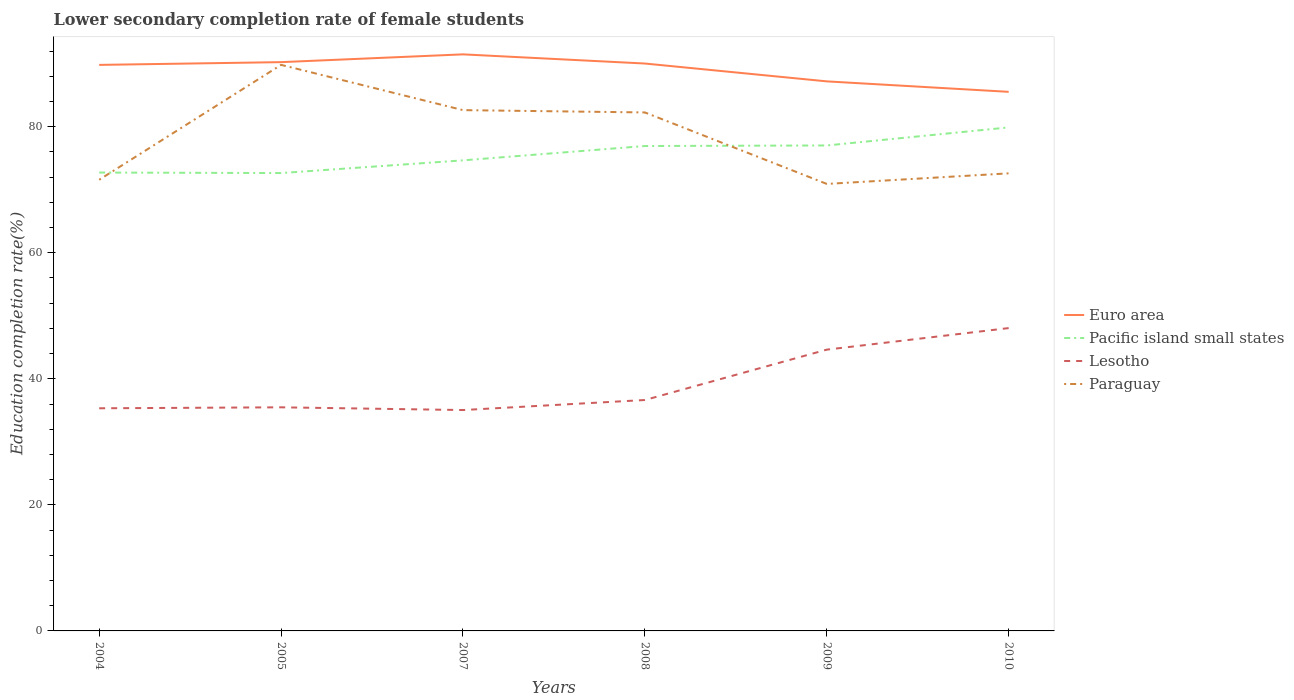Does the line corresponding to Lesotho intersect with the line corresponding to Paraguay?
Ensure brevity in your answer.  No. Across all years, what is the maximum lower secondary completion rate of female students in Euro area?
Ensure brevity in your answer.  85.53. What is the total lower secondary completion rate of female students in Lesotho in the graph?
Ensure brevity in your answer.  0.28. What is the difference between the highest and the second highest lower secondary completion rate of female students in Euro area?
Your response must be concise. 5.95. How many years are there in the graph?
Your response must be concise. 6. What is the difference between two consecutive major ticks on the Y-axis?
Your answer should be compact. 20. Where does the legend appear in the graph?
Ensure brevity in your answer.  Center right. How many legend labels are there?
Your response must be concise. 4. What is the title of the graph?
Your answer should be compact. Lower secondary completion rate of female students. What is the label or title of the X-axis?
Your response must be concise. Years. What is the label or title of the Y-axis?
Offer a very short reply. Education completion rate(%). What is the Education completion rate(%) of Euro area in 2004?
Your answer should be compact. 89.81. What is the Education completion rate(%) in Pacific island small states in 2004?
Your answer should be compact. 72.73. What is the Education completion rate(%) of Lesotho in 2004?
Make the answer very short. 35.32. What is the Education completion rate(%) of Paraguay in 2004?
Provide a succinct answer. 71.58. What is the Education completion rate(%) of Euro area in 2005?
Keep it short and to the point. 90.25. What is the Education completion rate(%) in Pacific island small states in 2005?
Give a very brief answer. 72.65. What is the Education completion rate(%) in Lesotho in 2005?
Ensure brevity in your answer.  35.48. What is the Education completion rate(%) of Paraguay in 2005?
Offer a very short reply. 89.81. What is the Education completion rate(%) in Euro area in 2007?
Keep it short and to the point. 91.48. What is the Education completion rate(%) of Pacific island small states in 2007?
Your answer should be compact. 74.66. What is the Education completion rate(%) of Lesotho in 2007?
Your answer should be very brief. 35.05. What is the Education completion rate(%) in Paraguay in 2007?
Offer a terse response. 82.63. What is the Education completion rate(%) in Euro area in 2008?
Your answer should be very brief. 90.03. What is the Education completion rate(%) in Pacific island small states in 2008?
Your answer should be compact. 76.94. What is the Education completion rate(%) in Lesotho in 2008?
Your answer should be compact. 36.64. What is the Education completion rate(%) of Paraguay in 2008?
Make the answer very short. 82.26. What is the Education completion rate(%) of Euro area in 2009?
Give a very brief answer. 87.19. What is the Education completion rate(%) in Pacific island small states in 2009?
Provide a succinct answer. 77.03. What is the Education completion rate(%) in Lesotho in 2009?
Offer a terse response. 44.63. What is the Education completion rate(%) in Paraguay in 2009?
Make the answer very short. 70.92. What is the Education completion rate(%) in Euro area in 2010?
Offer a very short reply. 85.53. What is the Education completion rate(%) in Pacific island small states in 2010?
Ensure brevity in your answer.  79.89. What is the Education completion rate(%) in Lesotho in 2010?
Offer a very short reply. 48.05. What is the Education completion rate(%) in Paraguay in 2010?
Make the answer very short. 72.6. Across all years, what is the maximum Education completion rate(%) of Euro area?
Offer a terse response. 91.48. Across all years, what is the maximum Education completion rate(%) of Pacific island small states?
Your response must be concise. 79.89. Across all years, what is the maximum Education completion rate(%) of Lesotho?
Provide a succinct answer. 48.05. Across all years, what is the maximum Education completion rate(%) in Paraguay?
Your response must be concise. 89.81. Across all years, what is the minimum Education completion rate(%) in Euro area?
Your answer should be very brief. 85.53. Across all years, what is the minimum Education completion rate(%) of Pacific island small states?
Ensure brevity in your answer.  72.65. Across all years, what is the minimum Education completion rate(%) of Lesotho?
Offer a very short reply. 35.05. Across all years, what is the minimum Education completion rate(%) of Paraguay?
Provide a short and direct response. 70.92. What is the total Education completion rate(%) of Euro area in the graph?
Your response must be concise. 534.29. What is the total Education completion rate(%) of Pacific island small states in the graph?
Give a very brief answer. 453.89. What is the total Education completion rate(%) of Lesotho in the graph?
Offer a very short reply. 235.16. What is the total Education completion rate(%) in Paraguay in the graph?
Offer a very short reply. 469.81. What is the difference between the Education completion rate(%) in Euro area in 2004 and that in 2005?
Offer a terse response. -0.44. What is the difference between the Education completion rate(%) of Pacific island small states in 2004 and that in 2005?
Provide a succinct answer. 0.08. What is the difference between the Education completion rate(%) of Lesotho in 2004 and that in 2005?
Your answer should be very brief. -0.15. What is the difference between the Education completion rate(%) in Paraguay in 2004 and that in 2005?
Offer a very short reply. -18.23. What is the difference between the Education completion rate(%) of Euro area in 2004 and that in 2007?
Provide a short and direct response. -1.67. What is the difference between the Education completion rate(%) in Pacific island small states in 2004 and that in 2007?
Ensure brevity in your answer.  -1.94. What is the difference between the Education completion rate(%) of Lesotho in 2004 and that in 2007?
Give a very brief answer. 0.28. What is the difference between the Education completion rate(%) in Paraguay in 2004 and that in 2007?
Give a very brief answer. -11.05. What is the difference between the Education completion rate(%) of Euro area in 2004 and that in 2008?
Your answer should be compact. -0.22. What is the difference between the Education completion rate(%) of Pacific island small states in 2004 and that in 2008?
Give a very brief answer. -4.21. What is the difference between the Education completion rate(%) in Lesotho in 2004 and that in 2008?
Your response must be concise. -1.31. What is the difference between the Education completion rate(%) of Paraguay in 2004 and that in 2008?
Your response must be concise. -10.68. What is the difference between the Education completion rate(%) of Euro area in 2004 and that in 2009?
Offer a very short reply. 2.61. What is the difference between the Education completion rate(%) in Pacific island small states in 2004 and that in 2009?
Give a very brief answer. -4.3. What is the difference between the Education completion rate(%) of Lesotho in 2004 and that in 2009?
Provide a short and direct response. -9.31. What is the difference between the Education completion rate(%) of Paraguay in 2004 and that in 2009?
Keep it short and to the point. 0.66. What is the difference between the Education completion rate(%) in Euro area in 2004 and that in 2010?
Give a very brief answer. 4.27. What is the difference between the Education completion rate(%) of Pacific island small states in 2004 and that in 2010?
Your answer should be compact. -7.16. What is the difference between the Education completion rate(%) in Lesotho in 2004 and that in 2010?
Give a very brief answer. -12.72. What is the difference between the Education completion rate(%) in Paraguay in 2004 and that in 2010?
Make the answer very short. -1.02. What is the difference between the Education completion rate(%) in Euro area in 2005 and that in 2007?
Provide a short and direct response. -1.23. What is the difference between the Education completion rate(%) in Pacific island small states in 2005 and that in 2007?
Offer a very short reply. -2.02. What is the difference between the Education completion rate(%) of Lesotho in 2005 and that in 2007?
Offer a terse response. 0.43. What is the difference between the Education completion rate(%) of Paraguay in 2005 and that in 2007?
Give a very brief answer. 7.18. What is the difference between the Education completion rate(%) in Euro area in 2005 and that in 2008?
Give a very brief answer. 0.22. What is the difference between the Education completion rate(%) in Pacific island small states in 2005 and that in 2008?
Provide a succinct answer. -4.29. What is the difference between the Education completion rate(%) of Lesotho in 2005 and that in 2008?
Give a very brief answer. -1.16. What is the difference between the Education completion rate(%) of Paraguay in 2005 and that in 2008?
Keep it short and to the point. 7.55. What is the difference between the Education completion rate(%) of Euro area in 2005 and that in 2009?
Provide a succinct answer. 3.05. What is the difference between the Education completion rate(%) in Pacific island small states in 2005 and that in 2009?
Provide a short and direct response. -4.38. What is the difference between the Education completion rate(%) of Lesotho in 2005 and that in 2009?
Your answer should be compact. -9.15. What is the difference between the Education completion rate(%) in Paraguay in 2005 and that in 2009?
Keep it short and to the point. 18.89. What is the difference between the Education completion rate(%) of Euro area in 2005 and that in 2010?
Give a very brief answer. 4.71. What is the difference between the Education completion rate(%) in Pacific island small states in 2005 and that in 2010?
Provide a short and direct response. -7.24. What is the difference between the Education completion rate(%) of Lesotho in 2005 and that in 2010?
Your answer should be very brief. -12.57. What is the difference between the Education completion rate(%) in Paraguay in 2005 and that in 2010?
Provide a succinct answer. 17.21. What is the difference between the Education completion rate(%) in Euro area in 2007 and that in 2008?
Provide a short and direct response. 1.45. What is the difference between the Education completion rate(%) in Pacific island small states in 2007 and that in 2008?
Provide a short and direct response. -2.27. What is the difference between the Education completion rate(%) in Lesotho in 2007 and that in 2008?
Provide a succinct answer. -1.59. What is the difference between the Education completion rate(%) in Paraguay in 2007 and that in 2008?
Offer a very short reply. 0.37. What is the difference between the Education completion rate(%) of Euro area in 2007 and that in 2009?
Provide a succinct answer. 4.29. What is the difference between the Education completion rate(%) in Pacific island small states in 2007 and that in 2009?
Give a very brief answer. -2.36. What is the difference between the Education completion rate(%) in Lesotho in 2007 and that in 2009?
Provide a short and direct response. -9.58. What is the difference between the Education completion rate(%) in Paraguay in 2007 and that in 2009?
Make the answer very short. 11.71. What is the difference between the Education completion rate(%) in Euro area in 2007 and that in 2010?
Your answer should be very brief. 5.95. What is the difference between the Education completion rate(%) in Pacific island small states in 2007 and that in 2010?
Your answer should be very brief. -5.23. What is the difference between the Education completion rate(%) in Lesotho in 2007 and that in 2010?
Keep it short and to the point. -13. What is the difference between the Education completion rate(%) in Paraguay in 2007 and that in 2010?
Provide a short and direct response. 10.03. What is the difference between the Education completion rate(%) of Euro area in 2008 and that in 2009?
Your response must be concise. 2.83. What is the difference between the Education completion rate(%) of Pacific island small states in 2008 and that in 2009?
Give a very brief answer. -0.09. What is the difference between the Education completion rate(%) of Lesotho in 2008 and that in 2009?
Offer a terse response. -7.99. What is the difference between the Education completion rate(%) of Paraguay in 2008 and that in 2009?
Provide a succinct answer. 11.34. What is the difference between the Education completion rate(%) in Euro area in 2008 and that in 2010?
Make the answer very short. 4.49. What is the difference between the Education completion rate(%) in Pacific island small states in 2008 and that in 2010?
Your response must be concise. -2.95. What is the difference between the Education completion rate(%) in Lesotho in 2008 and that in 2010?
Give a very brief answer. -11.41. What is the difference between the Education completion rate(%) of Paraguay in 2008 and that in 2010?
Your answer should be compact. 9.66. What is the difference between the Education completion rate(%) in Euro area in 2009 and that in 2010?
Your answer should be compact. 1.66. What is the difference between the Education completion rate(%) in Pacific island small states in 2009 and that in 2010?
Your answer should be compact. -2.86. What is the difference between the Education completion rate(%) in Lesotho in 2009 and that in 2010?
Your answer should be very brief. -3.42. What is the difference between the Education completion rate(%) in Paraguay in 2009 and that in 2010?
Make the answer very short. -1.68. What is the difference between the Education completion rate(%) of Euro area in 2004 and the Education completion rate(%) of Pacific island small states in 2005?
Ensure brevity in your answer.  17.16. What is the difference between the Education completion rate(%) in Euro area in 2004 and the Education completion rate(%) in Lesotho in 2005?
Make the answer very short. 54.33. What is the difference between the Education completion rate(%) of Euro area in 2004 and the Education completion rate(%) of Paraguay in 2005?
Your answer should be very brief. -0. What is the difference between the Education completion rate(%) of Pacific island small states in 2004 and the Education completion rate(%) of Lesotho in 2005?
Your answer should be compact. 37.25. What is the difference between the Education completion rate(%) in Pacific island small states in 2004 and the Education completion rate(%) in Paraguay in 2005?
Make the answer very short. -17.08. What is the difference between the Education completion rate(%) of Lesotho in 2004 and the Education completion rate(%) of Paraguay in 2005?
Keep it short and to the point. -54.49. What is the difference between the Education completion rate(%) of Euro area in 2004 and the Education completion rate(%) of Pacific island small states in 2007?
Provide a short and direct response. 15.15. What is the difference between the Education completion rate(%) in Euro area in 2004 and the Education completion rate(%) in Lesotho in 2007?
Ensure brevity in your answer.  54.76. What is the difference between the Education completion rate(%) in Euro area in 2004 and the Education completion rate(%) in Paraguay in 2007?
Offer a very short reply. 7.18. What is the difference between the Education completion rate(%) in Pacific island small states in 2004 and the Education completion rate(%) in Lesotho in 2007?
Offer a terse response. 37.68. What is the difference between the Education completion rate(%) in Pacific island small states in 2004 and the Education completion rate(%) in Paraguay in 2007?
Your response must be concise. -9.9. What is the difference between the Education completion rate(%) in Lesotho in 2004 and the Education completion rate(%) in Paraguay in 2007?
Your answer should be very brief. -47.31. What is the difference between the Education completion rate(%) in Euro area in 2004 and the Education completion rate(%) in Pacific island small states in 2008?
Provide a succinct answer. 12.87. What is the difference between the Education completion rate(%) in Euro area in 2004 and the Education completion rate(%) in Lesotho in 2008?
Make the answer very short. 53.17. What is the difference between the Education completion rate(%) of Euro area in 2004 and the Education completion rate(%) of Paraguay in 2008?
Make the answer very short. 7.54. What is the difference between the Education completion rate(%) of Pacific island small states in 2004 and the Education completion rate(%) of Lesotho in 2008?
Offer a very short reply. 36.09. What is the difference between the Education completion rate(%) of Pacific island small states in 2004 and the Education completion rate(%) of Paraguay in 2008?
Provide a short and direct response. -9.54. What is the difference between the Education completion rate(%) in Lesotho in 2004 and the Education completion rate(%) in Paraguay in 2008?
Provide a succinct answer. -46.94. What is the difference between the Education completion rate(%) of Euro area in 2004 and the Education completion rate(%) of Pacific island small states in 2009?
Provide a short and direct response. 12.78. What is the difference between the Education completion rate(%) in Euro area in 2004 and the Education completion rate(%) in Lesotho in 2009?
Offer a terse response. 45.18. What is the difference between the Education completion rate(%) of Euro area in 2004 and the Education completion rate(%) of Paraguay in 2009?
Offer a very short reply. 18.88. What is the difference between the Education completion rate(%) of Pacific island small states in 2004 and the Education completion rate(%) of Lesotho in 2009?
Ensure brevity in your answer.  28.1. What is the difference between the Education completion rate(%) of Pacific island small states in 2004 and the Education completion rate(%) of Paraguay in 2009?
Your response must be concise. 1.8. What is the difference between the Education completion rate(%) of Lesotho in 2004 and the Education completion rate(%) of Paraguay in 2009?
Your answer should be compact. -35.6. What is the difference between the Education completion rate(%) in Euro area in 2004 and the Education completion rate(%) in Pacific island small states in 2010?
Your answer should be very brief. 9.92. What is the difference between the Education completion rate(%) in Euro area in 2004 and the Education completion rate(%) in Lesotho in 2010?
Provide a short and direct response. 41.76. What is the difference between the Education completion rate(%) in Euro area in 2004 and the Education completion rate(%) in Paraguay in 2010?
Offer a terse response. 17.21. What is the difference between the Education completion rate(%) of Pacific island small states in 2004 and the Education completion rate(%) of Lesotho in 2010?
Provide a succinct answer. 24.68. What is the difference between the Education completion rate(%) in Pacific island small states in 2004 and the Education completion rate(%) in Paraguay in 2010?
Provide a short and direct response. 0.13. What is the difference between the Education completion rate(%) of Lesotho in 2004 and the Education completion rate(%) of Paraguay in 2010?
Offer a very short reply. -37.28. What is the difference between the Education completion rate(%) of Euro area in 2005 and the Education completion rate(%) of Pacific island small states in 2007?
Offer a very short reply. 15.58. What is the difference between the Education completion rate(%) of Euro area in 2005 and the Education completion rate(%) of Lesotho in 2007?
Offer a terse response. 55.2. What is the difference between the Education completion rate(%) in Euro area in 2005 and the Education completion rate(%) in Paraguay in 2007?
Provide a succinct answer. 7.61. What is the difference between the Education completion rate(%) in Pacific island small states in 2005 and the Education completion rate(%) in Lesotho in 2007?
Offer a very short reply. 37.6. What is the difference between the Education completion rate(%) in Pacific island small states in 2005 and the Education completion rate(%) in Paraguay in 2007?
Your response must be concise. -9.98. What is the difference between the Education completion rate(%) in Lesotho in 2005 and the Education completion rate(%) in Paraguay in 2007?
Your response must be concise. -47.15. What is the difference between the Education completion rate(%) in Euro area in 2005 and the Education completion rate(%) in Pacific island small states in 2008?
Offer a terse response. 13.31. What is the difference between the Education completion rate(%) in Euro area in 2005 and the Education completion rate(%) in Lesotho in 2008?
Your answer should be very brief. 53.61. What is the difference between the Education completion rate(%) of Euro area in 2005 and the Education completion rate(%) of Paraguay in 2008?
Offer a very short reply. 7.98. What is the difference between the Education completion rate(%) in Pacific island small states in 2005 and the Education completion rate(%) in Lesotho in 2008?
Provide a short and direct response. 36.01. What is the difference between the Education completion rate(%) of Pacific island small states in 2005 and the Education completion rate(%) of Paraguay in 2008?
Your response must be concise. -9.62. What is the difference between the Education completion rate(%) of Lesotho in 2005 and the Education completion rate(%) of Paraguay in 2008?
Provide a short and direct response. -46.79. What is the difference between the Education completion rate(%) in Euro area in 2005 and the Education completion rate(%) in Pacific island small states in 2009?
Offer a terse response. 13.22. What is the difference between the Education completion rate(%) of Euro area in 2005 and the Education completion rate(%) of Lesotho in 2009?
Your answer should be compact. 45.62. What is the difference between the Education completion rate(%) in Euro area in 2005 and the Education completion rate(%) in Paraguay in 2009?
Give a very brief answer. 19.32. What is the difference between the Education completion rate(%) in Pacific island small states in 2005 and the Education completion rate(%) in Lesotho in 2009?
Your answer should be compact. 28.02. What is the difference between the Education completion rate(%) in Pacific island small states in 2005 and the Education completion rate(%) in Paraguay in 2009?
Your answer should be very brief. 1.72. What is the difference between the Education completion rate(%) of Lesotho in 2005 and the Education completion rate(%) of Paraguay in 2009?
Provide a succinct answer. -35.45. What is the difference between the Education completion rate(%) in Euro area in 2005 and the Education completion rate(%) in Pacific island small states in 2010?
Offer a terse response. 10.36. What is the difference between the Education completion rate(%) of Euro area in 2005 and the Education completion rate(%) of Lesotho in 2010?
Your response must be concise. 42.2. What is the difference between the Education completion rate(%) of Euro area in 2005 and the Education completion rate(%) of Paraguay in 2010?
Your response must be concise. 17.64. What is the difference between the Education completion rate(%) in Pacific island small states in 2005 and the Education completion rate(%) in Lesotho in 2010?
Provide a short and direct response. 24.6. What is the difference between the Education completion rate(%) in Pacific island small states in 2005 and the Education completion rate(%) in Paraguay in 2010?
Give a very brief answer. 0.05. What is the difference between the Education completion rate(%) in Lesotho in 2005 and the Education completion rate(%) in Paraguay in 2010?
Your answer should be very brief. -37.12. What is the difference between the Education completion rate(%) in Euro area in 2007 and the Education completion rate(%) in Pacific island small states in 2008?
Your answer should be very brief. 14.54. What is the difference between the Education completion rate(%) in Euro area in 2007 and the Education completion rate(%) in Lesotho in 2008?
Provide a succinct answer. 54.84. What is the difference between the Education completion rate(%) in Euro area in 2007 and the Education completion rate(%) in Paraguay in 2008?
Provide a short and direct response. 9.22. What is the difference between the Education completion rate(%) in Pacific island small states in 2007 and the Education completion rate(%) in Lesotho in 2008?
Keep it short and to the point. 38.03. What is the difference between the Education completion rate(%) in Pacific island small states in 2007 and the Education completion rate(%) in Paraguay in 2008?
Offer a very short reply. -7.6. What is the difference between the Education completion rate(%) of Lesotho in 2007 and the Education completion rate(%) of Paraguay in 2008?
Your answer should be very brief. -47.22. What is the difference between the Education completion rate(%) of Euro area in 2007 and the Education completion rate(%) of Pacific island small states in 2009?
Provide a succinct answer. 14.45. What is the difference between the Education completion rate(%) of Euro area in 2007 and the Education completion rate(%) of Lesotho in 2009?
Ensure brevity in your answer.  46.85. What is the difference between the Education completion rate(%) of Euro area in 2007 and the Education completion rate(%) of Paraguay in 2009?
Provide a short and direct response. 20.56. What is the difference between the Education completion rate(%) in Pacific island small states in 2007 and the Education completion rate(%) in Lesotho in 2009?
Provide a short and direct response. 30.03. What is the difference between the Education completion rate(%) in Pacific island small states in 2007 and the Education completion rate(%) in Paraguay in 2009?
Provide a succinct answer. 3.74. What is the difference between the Education completion rate(%) of Lesotho in 2007 and the Education completion rate(%) of Paraguay in 2009?
Your answer should be very brief. -35.88. What is the difference between the Education completion rate(%) of Euro area in 2007 and the Education completion rate(%) of Pacific island small states in 2010?
Offer a very short reply. 11.59. What is the difference between the Education completion rate(%) of Euro area in 2007 and the Education completion rate(%) of Lesotho in 2010?
Provide a short and direct response. 43.43. What is the difference between the Education completion rate(%) in Euro area in 2007 and the Education completion rate(%) in Paraguay in 2010?
Your answer should be very brief. 18.88. What is the difference between the Education completion rate(%) of Pacific island small states in 2007 and the Education completion rate(%) of Lesotho in 2010?
Offer a very short reply. 26.61. What is the difference between the Education completion rate(%) of Pacific island small states in 2007 and the Education completion rate(%) of Paraguay in 2010?
Ensure brevity in your answer.  2.06. What is the difference between the Education completion rate(%) of Lesotho in 2007 and the Education completion rate(%) of Paraguay in 2010?
Your answer should be compact. -37.56. What is the difference between the Education completion rate(%) in Euro area in 2008 and the Education completion rate(%) in Pacific island small states in 2009?
Offer a terse response. 13. What is the difference between the Education completion rate(%) of Euro area in 2008 and the Education completion rate(%) of Lesotho in 2009?
Provide a short and direct response. 45.4. What is the difference between the Education completion rate(%) in Euro area in 2008 and the Education completion rate(%) in Paraguay in 2009?
Offer a very short reply. 19.1. What is the difference between the Education completion rate(%) in Pacific island small states in 2008 and the Education completion rate(%) in Lesotho in 2009?
Offer a very short reply. 32.31. What is the difference between the Education completion rate(%) in Pacific island small states in 2008 and the Education completion rate(%) in Paraguay in 2009?
Ensure brevity in your answer.  6.01. What is the difference between the Education completion rate(%) of Lesotho in 2008 and the Education completion rate(%) of Paraguay in 2009?
Make the answer very short. -34.29. What is the difference between the Education completion rate(%) in Euro area in 2008 and the Education completion rate(%) in Pacific island small states in 2010?
Your answer should be compact. 10.14. What is the difference between the Education completion rate(%) in Euro area in 2008 and the Education completion rate(%) in Lesotho in 2010?
Keep it short and to the point. 41.98. What is the difference between the Education completion rate(%) of Euro area in 2008 and the Education completion rate(%) of Paraguay in 2010?
Keep it short and to the point. 17.42. What is the difference between the Education completion rate(%) of Pacific island small states in 2008 and the Education completion rate(%) of Lesotho in 2010?
Offer a very short reply. 28.89. What is the difference between the Education completion rate(%) of Pacific island small states in 2008 and the Education completion rate(%) of Paraguay in 2010?
Provide a succinct answer. 4.33. What is the difference between the Education completion rate(%) in Lesotho in 2008 and the Education completion rate(%) in Paraguay in 2010?
Provide a short and direct response. -35.96. What is the difference between the Education completion rate(%) of Euro area in 2009 and the Education completion rate(%) of Pacific island small states in 2010?
Make the answer very short. 7.31. What is the difference between the Education completion rate(%) of Euro area in 2009 and the Education completion rate(%) of Lesotho in 2010?
Keep it short and to the point. 39.14. What is the difference between the Education completion rate(%) in Euro area in 2009 and the Education completion rate(%) in Paraguay in 2010?
Keep it short and to the point. 14.59. What is the difference between the Education completion rate(%) in Pacific island small states in 2009 and the Education completion rate(%) in Lesotho in 2010?
Your response must be concise. 28.98. What is the difference between the Education completion rate(%) in Pacific island small states in 2009 and the Education completion rate(%) in Paraguay in 2010?
Offer a terse response. 4.42. What is the difference between the Education completion rate(%) of Lesotho in 2009 and the Education completion rate(%) of Paraguay in 2010?
Offer a terse response. -27.97. What is the average Education completion rate(%) in Euro area per year?
Provide a succinct answer. 89.05. What is the average Education completion rate(%) in Pacific island small states per year?
Keep it short and to the point. 75.65. What is the average Education completion rate(%) in Lesotho per year?
Provide a short and direct response. 39.19. What is the average Education completion rate(%) of Paraguay per year?
Give a very brief answer. 78.3. In the year 2004, what is the difference between the Education completion rate(%) of Euro area and Education completion rate(%) of Pacific island small states?
Your answer should be compact. 17.08. In the year 2004, what is the difference between the Education completion rate(%) of Euro area and Education completion rate(%) of Lesotho?
Make the answer very short. 54.48. In the year 2004, what is the difference between the Education completion rate(%) in Euro area and Education completion rate(%) in Paraguay?
Your answer should be very brief. 18.23. In the year 2004, what is the difference between the Education completion rate(%) of Pacific island small states and Education completion rate(%) of Lesotho?
Make the answer very short. 37.4. In the year 2004, what is the difference between the Education completion rate(%) of Pacific island small states and Education completion rate(%) of Paraguay?
Your response must be concise. 1.15. In the year 2004, what is the difference between the Education completion rate(%) of Lesotho and Education completion rate(%) of Paraguay?
Offer a very short reply. -36.26. In the year 2005, what is the difference between the Education completion rate(%) in Euro area and Education completion rate(%) in Pacific island small states?
Make the answer very short. 17.6. In the year 2005, what is the difference between the Education completion rate(%) of Euro area and Education completion rate(%) of Lesotho?
Ensure brevity in your answer.  54.77. In the year 2005, what is the difference between the Education completion rate(%) of Euro area and Education completion rate(%) of Paraguay?
Your answer should be very brief. 0.43. In the year 2005, what is the difference between the Education completion rate(%) in Pacific island small states and Education completion rate(%) in Lesotho?
Give a very brief answer. 37.17. In the year 2005, what is the difference between the Education completion rate(%) of Pacific island small states and Education completion rate(%) of Paraguay?
Your response must be concise. -17.17. In the year 2005, what is the difference between the Education completion rate(%) in Lesotho and Education completion rate(%) in Paraguay?
Offer a terse response. -54.33. In the year 2007, what is the difference between the Education completion rate(%) in Euro area and Education completion rate(%) in Pacific island small states?
Provide a succinct answer. 16.82. In the year 2007, what is the difference between the Education completion rate(%) in Euro area and Education completion rate(%) in Lesotho?
Keep it short and to the point. 56.43. In the year 2007, what is the difference between the Education completion rate(%) of Euro area and Education completion rate(%) of Paraguay?
Your answer should be very brief. 8.85. In the year 2007, what is the difference between the Education completion rate(%) of Pacific island small states and Education completion rate(%) of Lesotho?
Your response must be concise. 39.62. In the year 2007, what is the difference between the Education completion rate(%) in Pacific island small states and Education completion rate(%) in Paraguay?
Your answer should be very brief. -7.97. In the year 2007, what is the difference between the Education completion rate(%) in Lesotho and Education completion rate(%) in Paraguay?
Make the answer very short. -47.59. In the year 2008, what is the difference between the Education completion rate(%) in Euro area and Education completion rate(%) in Pacific island small states?
Give a very brief answer. 13.09. In the year 2008, what is the difference between the Education completion rate(%) in Euro area and Education completion rate(%) in Lesotho?
Provide a short and direct response. 53.39. In the year 2008, what is the difference between the Education completion rate(%) of Euro area and Education completion rate(%) of Paraguay?
Your answer should be very brief. 7.76. In the year 2008, what is the difference between the Education completion rate(%) in Pacific island small states and Education completion rate(%) in Lesotho?
Offer a very short reply. 40.3. In the year 2008, what is the difference between the Education completion rate(%) of Pacific island small states and Education completion rate(%) of Paraguay?
Your answer should be very brief. -5.33. In the year 2008, what is the difference between the Education completion rate(%) in Lesotho and Education completion rate(%) in Paraguay?
Provide a short and direct response. -45.63. In the year 2009, what is the difference between the Education completion rate(%) in Euro area and Education completion rate(%) in Pacific island small states?
Ensure brevity in your answer.  10.17. In the year 2009, what is the difference between the Education completion rate(%) in Euro area and Education completion rate(%) in Lesotho?
Provide a succinct answer. 42.56. In the year 2009, what is the difference between the Education completion rate(%) in Euro area and Education completion rate(%) in Paraguay?
Ensure brevity in your answer.  16.27. In the year 2009, what is the difference between the Education completion rate(%) of Pacific island small states and Education completion rate(%) of Lesotho?
Keep it short and to the point. 32.4. In the year 2009, what is the difference between the Education completion rate(%) of Pacific island small states and Education completion rate(%) of Paraguay?
Keep it short and to the point. 6.1. In the year 2009, what is the difference between the Education completion rate(%) of Lesotho and Education completion rate(%) of Paraguay?
Provide a short and direct response. -26.29. In the year 2010, what is the difference between the Education completion rate(%) in Euro area and Education completion rate(%) in Pacific island small states?
Make the answer very short. 5.64. In the year 2010, what is the difference between the Education completion rate(%) of Euro area and Education completion rate(%) of Lesotho?
Your response must be concise. 37.48. In the year 2010, what is the difference between the Education completion rate(%) of Euro area and Education completion rate(%) of Paraguay?
Give a very brief answer. 12.93. In the year 2010, what is the difference between the Education completion rate(%) in Pacific island small states and Education completion rate(%) in Lesotho?
Your answer should be compact. 31.84. In the year 2010, what is the difference between the Education completion rate(%) in Pacific island small states and Education completion rate(%) in Paraguay?
Your response must be concise. 7.29. In the year 2010, what is the difference between the Education completion rate(%) in Lesotho and Education completion rate(%) in Paraguay?
Provide a succinct answer. -24.55. What is the ratio of the Education completion rate(%) of Pacific island small states in 2004 to that in 2005?
Provide a short and direct response. 1. What is the ratio of the Education completion rate(%) in Paraguay in 2004 to that in 2005?
Provide a short and direct response. 0.8. What is the ratio of the Education completion rate(%) in Euro area in 2004 to that in 2007?
Your answer should be very brief. 0.98. What is the ratio of the Education completion rate(%) of Pacific island small states in 2004 to that in 2007?
Provide a succinct answer. 0.97. What is the ratio of the Education completion rate(%) in Lesotho in 2004 to that in 2007?
Ensure brevity in your answer.  1.01. What is the ratio of the Education completion rate(%) in Paraguay in 2004 to that in 2007?
Provide a short and direct response. 0.87. What is the ratio of the Education completion rate(%) in Pacific island small states in 2004 to that in 2008?
Offer a very short reply. 0.95. What is the ratio of the Education completion rate(%) in Lesotho in 2004 to that in 2008?
Your response must be concise. 0.96. What is the ratio of the Education completion rate(%) in Paraguay in 2004 to that in 2008?
Ensure brevity in your answer.  0.87. What is the ratio of the Education completion rate(%) in Euro area in 2004 to that in 2009?
Offer a very short reply. 1.03. What is the ratio of the Education completion rate(%) of Pacific island small states in 2004 to that in 2009?
Provide a succinct answer. 0.94. What is the ratio of the Education completion rate(%) of Lesotho in 2004 to that in 2009?
Keep it short and to the point. 0.79. What is the ratio of the Education completion rate(%) of Paraguay in 2004 to that in 2009?
Your response must be concise. 1.01. What is the ratio of the Education completion rate(%) of Pacific island small states in 2004 to that in 2010?
Offer a very short reply. 0.91. What is the ratio of the Education completion rate(%) in Lesotho in 2004 to that in 2010?
Your answer should be very brief. 0.74. What is the ratio of the Education completion rate(%) of Paraguay in 2004 to that in 2010?
Provide a succinct answer. 0.99. What is the ratio of the Education completion rate(%) of Euro area in 2005 to that in 2007?
Provide a succinct answer. 0.99. What is the ratio of the Education completion rate(%) in Pacific island small states in 2005 to that in 2007?
Offer a terse response. 0.97. What is the ratio of the Education completion rate(%) of Lesotho in 2005 to that in 2007?
Make the answer very short. 1.01. What is the ratio of the Education completion rate(%) in Paraguay in 2005 to that in 2007?
Provide a succinct answer. 1.09. What is the ratio of the Education completion rate(%) in Pacific island small states in 2005 to that in 2008?
Keep it short and to the point. 0.94. What is the ratio of the Education completion rate(%) of Lesotho in 2005 to that in 2008?
Make the answer very short. 0.97. What is the ratio of the Education completion rate(%) in Paraguay in 2005 to that in 2008?
Offer a very short reply. 1.09. What is the ratio of the Education completion rate(%) in Euro area in 2005 to that in 2009?
Make the answer very short. 1.03. What is the ratio of the Education completion rate(%) in Pacific island small states in 2005 to that in 2009?
Your response must be concise. 0.94. What is the ratio of the Education completion rate(%) of Lesotho in 2005 to that in 2009?
Provide a short and direct response. 0.79. What is the ratio of the Education completion rate(%) in Paraguay in 2005 to that in 2009?
Your answer should be very brief. 1.27. What is the ratio of the Education completion rate(%) of Euro area in 2005 to that in 2010?
Provide a succinct answer. 1.06. What is the ratio of the Education completion rate(%) of Pacific island small states in 2005 to that in 2010?
Offer a very short reply. 0.91. What is the ratio of the Education completion rate(%) of Lesotho in 2005 to that in 2010?
Keep it short and to the point. 0.74. What is the ratio of the Education completion rate(%) of Paraguay in 2005 to that in 2010?
Your answer should be compact. 1.24. What is the ratio of the Education completion rate(%) in Euro area in 2007 to that in 2008?
Offer a terse response. 1.02. What is the ratio of the Education completion rate(%) in Pacific island small states in 2007 to that in 2008?
Your answer should be compact. 0.97. What is the ratio of the Education completion rate(%) in Lesotho in 2007 to that in 2008?
Your response must be concise. 0.96. What is the ratio of the Education completion rate(%) of Euro area in 2007 to that in 2009?
Provide a short and direct response. 1.05. What is the ratio of the Education completion rate(%) in Pacific island small states in 2007 to that in 2009?
Give a very brief answer. 0.97. What is the ratio of the Education completion rate(%) of Lesotho in 2007 to that in 2009?
Give a very brief answer. 0.79. What is the ratio of the Education completion rate(%) in Paraguay in 2007 to that in 2009?
Keep it short and to the point. 1.17. What is the ratio of the Education completion rate(%) of Euro area in 2007 to that in 2010?
Your answer should be compact. 1.07. What is the ratio of the Education completion rate(%) in Pacific island small states in 2007 to that in 2010?
Your answer should be very brief. 0.93. What is the ratio of the Education completion rate(%) in Lesotho in 2007 to that in 2010?
Provide a succinct answer. 0.73. What is the ratio of the Education completion rate(%) of Paraguay in 2007 to that in 2010?
Keep it short and to the point. 1.14. What is the ratio of the Education completion rate(%) in Euro area in 2008 to that in 2009?
Offer a terse response. 1.03. What is the ratio of the Education completion rate(%) in Lesotho in 2008 to that in 2009?
Provide a succinct answer. 0.82. What is the ratio of the Education completion rate(%) of Paraguay in 2008 to that in 2009?
Offer a very short reply. 1.16. What is the ratio of the Education completion rate(%) in Euro area in 2008 to that in 2010?
Offer a terse response. 1.05. What is the ratio of the Education completion rate(%) of Pacific island small states in 2008 to that in 2010?
Provide a succinct answer. 0.96. What is the ratio of the Education completion rate(%) in Lesotho in 2008 to that in 2010?
Your answer should be compact. 0.76. What is the ratio of the Education completion rate(%) of Paraguay in 2008 to that in 2010?
Give a very brief answer. 1.13. What is the ratio of the Education completion rate(%) of Euro area in 2009 to that in 2010?
Give a very brief answer. 1.02. What is the ratio of the Education completion rate(%) in Pacific island small states in 2009 to that in 2010?
Your response must be concise. 0.96. What is the ratio of the Education completion rate(%) in Lesotho in 2009 to that in 2010?
Give a very brief answer. 0.93. What is the ratio of the Education completion rate(%) in Paraguay in 2009 to that in 2010?
Your answer should be very brief. 0.98. What is the difference between the highest and the second highest Education completion rate(%) in Euro area?
Keep it short and to the point. 1.23. What is the difference between the highest and the second highest Education completion rate(%) of Pacific island small states?
Your answer should be compact. 2.86. What is the difference between the highest and the second highest Education completion rate(%) of Lesotho?
Your answer should be compact. 3.42. What is the difference between the highest and the second highest Education completion rate(%) of Paraguay?
Your answer should be compact. 7.18. What is the difference between the highest and the lowest Education completion rate(%) in Euro area?
Make the answer very short. 5.95. What is the difference between the highest and the lowest Education completion rate(%) in Pacific island small states?
Your answer should be very brief. 7.24. What is the difference between the highest and the lowest Education completion rate(%) in Lesotho?
Provide a succinct answer. 13. What is the difference between the highest and the lowest Education completion rate(%) in Paraguay?
Ensure brevity in your answer.  18.89. 